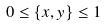Convert formula to latex. <formula><loc_0><loc_0><loc_500><loc_500>0 \leq \{ x , y \} \leq 1</formula> 